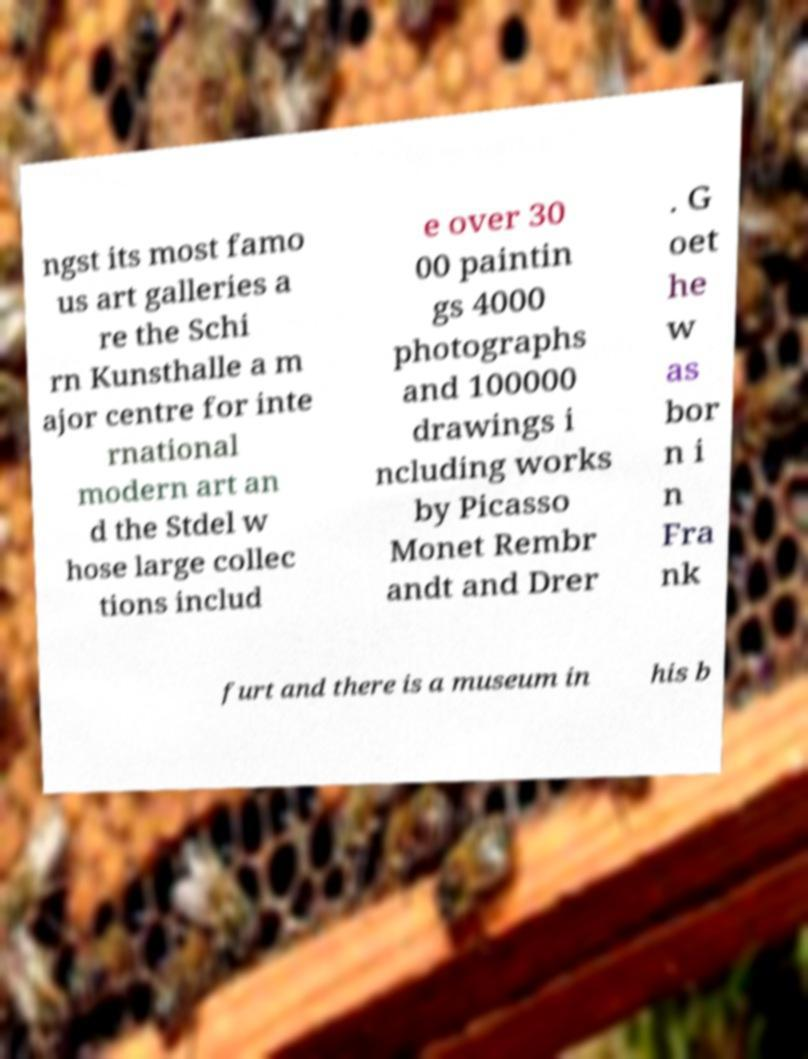What messages or text are displayed in this image? I need them in a readable, typed format. ngst its most famo us art galleries a re the Schi rn Kunsthalle a m ajor centre for inte rnational modern art an d the Stdel w hose large collec tions includ e over 30 00 paintin gs 4000 photographs and 100000 drawings i ncluding works by Picasso Monet Rembr andt and Drer . G oet he w as bor n i n Fra nk furt and there is a museum in his b 